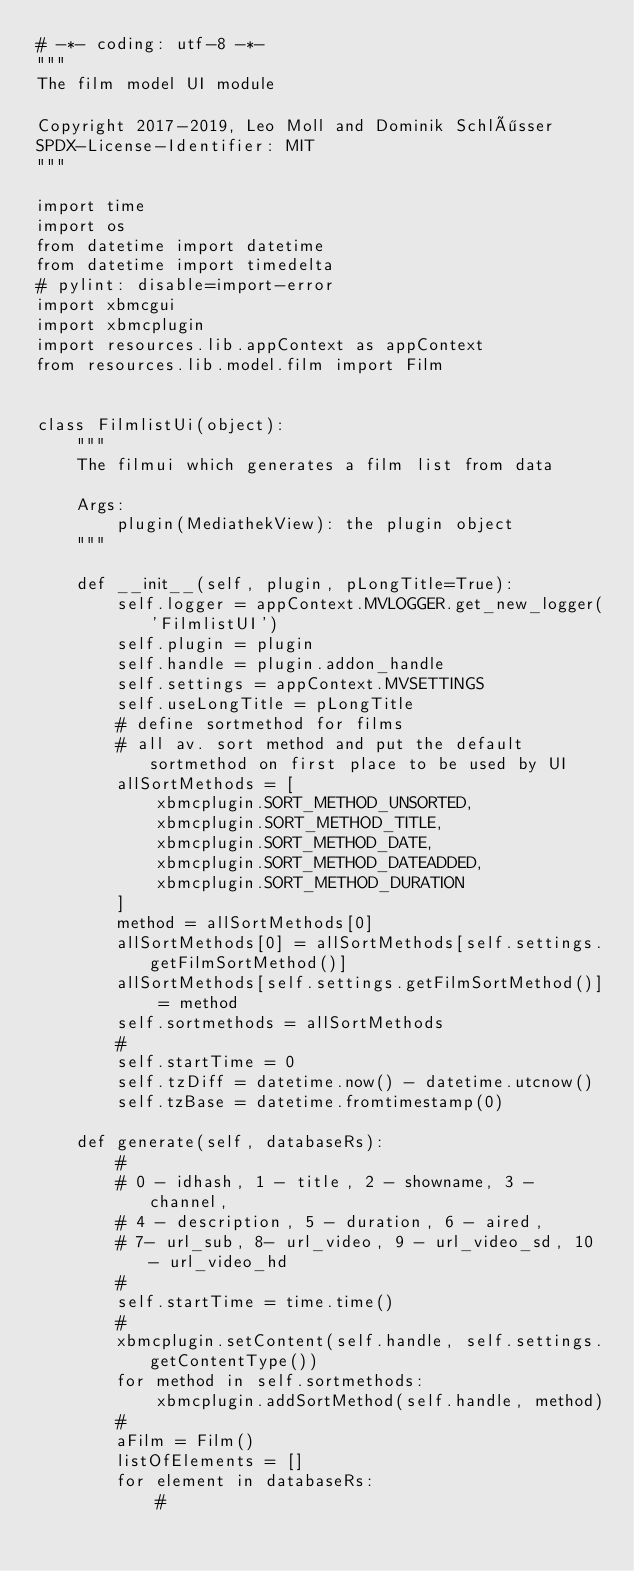<code> <loc_0><loc_0><loc_500><loc_500><_Python_># -*- coding: utf-8 -*-
"""
The film model UI module

Copyright 2017-2019, Leo Moll and Dominik Schlösser
SPDX-License-Identifier: MIT
"""

import time
import os
from datetime import datetime
from datetime import timedelta
# pylint: disable=import-error
import xbmcgui
import xbmcplugin
import resources.lib.appContext as appContext
from resources.lib.model.film import Film


class FilmlistUi(object):
    """
    The filmui which generates a film list from data

    Args:
        plugin(MediathekView): the plugin object
    """

    def __init__(self, plugin, pLongTitle=True):
        self.logger = appContext.MVLOGGER.get_new_logger('FilmlistUI')
        self.plugin = plugin
        self.handle = plugin.addon_handle
        self.settings = appContext.MVSETTINGS
        self.useLongTitle = pLongTitle
        # define sortmethod for films
        # all av. sort method and put the default sortmethod on first place to be used by UI
        allSortMethods = [
            xbmcplugin.SORT_METHOD_UNSORTED,
            xbmcplugin.SORT_METHOD_TITLE,
            xbmcplugin.SORT_METHOD_DATE,
            xbmcplugin.SORT_METHOD_DATEADDED,
            xbmcplugin.SORT_METHOD_DURATION
        ]
        method = allSortMethods[0]
        allSortMethods[0] = allSortMethods[self.settings.getFilmSortMethod()]
        allSortMethods[self.settings.getFilmSortMethod()] = method
        self.sortmethods = allSortMethods
        #
        self.startTime = 0
        self.tzDiff = datetime.now() - datetime.utcnow()
        self.tzBase = datetime.fromtimestamp(0)

    def generate(self, databaseRs):
        #
        # 0 - idhash, 1 - title, 2 - showname, 3 - channel,
        # 4 - description, 5 - duration, 6 - aired,
        # 7- url_sub, 8- url_video, 9 - url_video_sd, 10 - url_video_hd
        #
        self.startTime = time.time()
        #
        xbmcplugin.setContent(self.handle, self.settings.getContentType())
        for method in self.sortmethods:
            xbmcplugin.addSortMethod(self.handle, method)
        #
        aFilm = Film()
        listOfElements = []
        for element in databaseRs:
            #</code> 